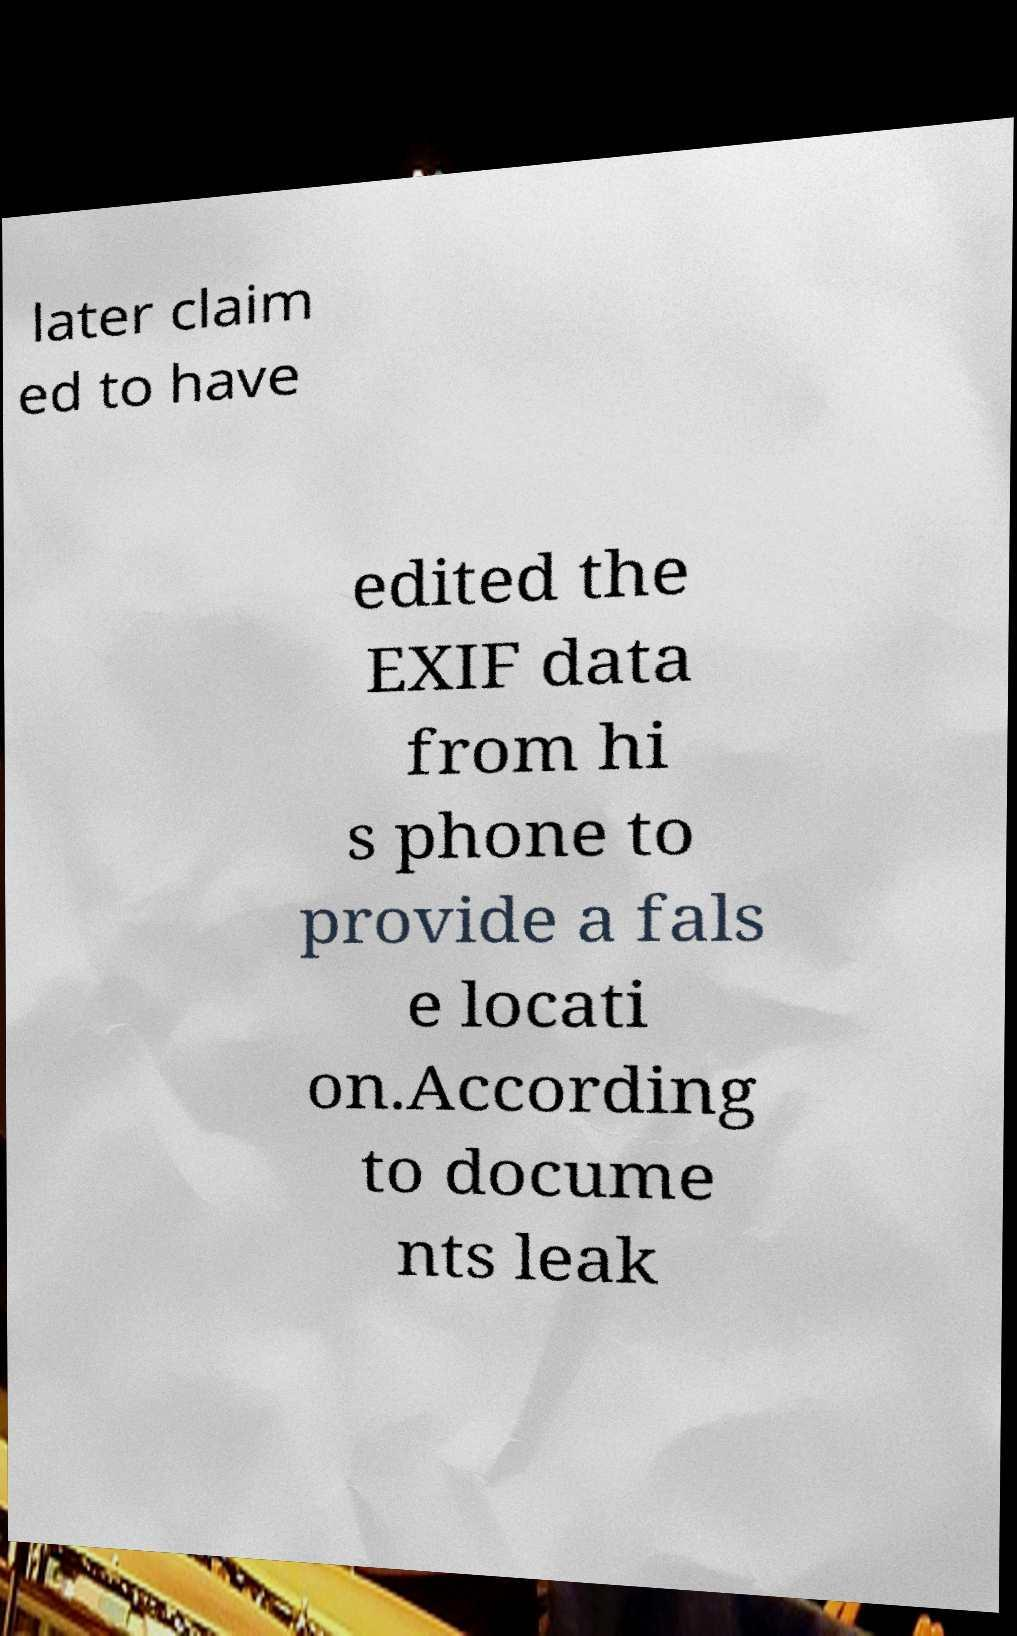I need the written content from this picture converted into text. Can you do that? later claim ed to have edited the EXIF data from hi s phone to provide a fals e locati on.According to docume nts leak 